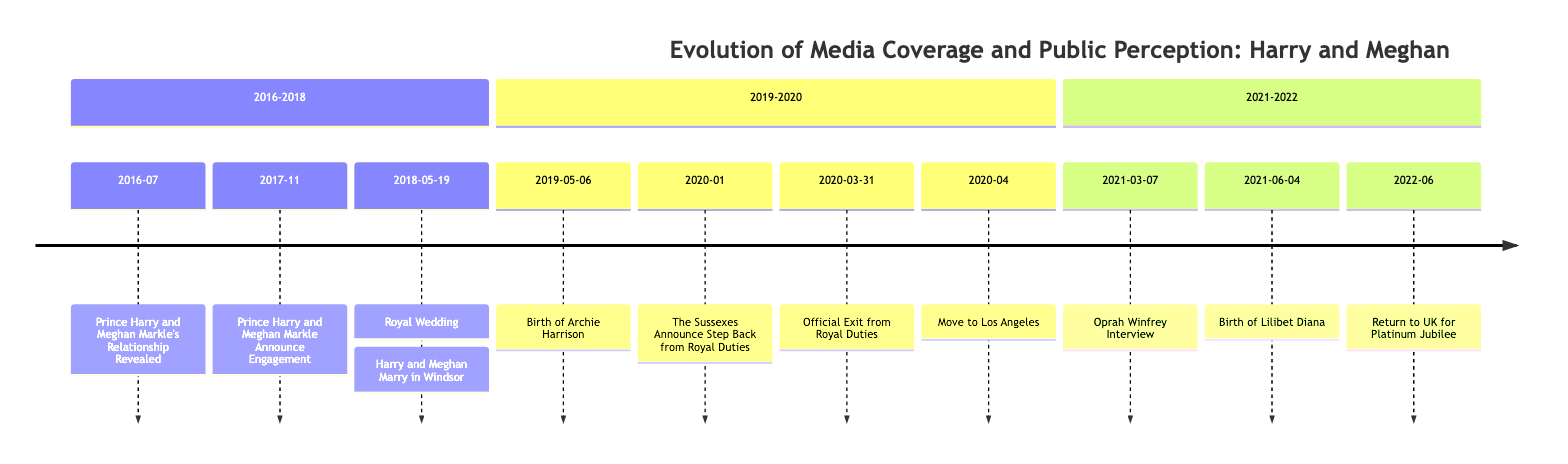What event is marked on 2016-07? The diagram clearly displays that on 2016-07, the event is "Prince Harry and Meghan Markle's Relationship Revealed." This can be seen as a headline under the timeline section.
Answer: Prince Harry and Meghan Markle's Relationship Revealed How many events are listed in the section 2019-2020? In the section titled "2019-2020," there are four events listed: the birth of Archie Harrison, the Sussexes' announcement to step back from royal duties, their official exit from royal duties, and their move to Los Angeles. This can be counted directly from the diagram.
Answer: 4 What major interview was conducted in March 2021? The diagram indicates that the major interview in March 2021 was the "Oprah Winfrey Interview," as it is the headline listed for that date. Therefore, we can directly identify it from the timeline.
Answer: Oprah Winfrey Interview When did the Sussexes officially exit from royal duties? The timeline specifies that the official exit from royal duties took place on 2020-03-31, as this headline is stated right under that date.
Answer: 2020-03-31 Which significant event occurred after the birth of Archie Harrison? From the timeline, it can be noted that after the birth of Archie Harrison on 2019-05-06, the next significant event is the Sussexes' announcement in January 2020 regarding stepping back from royal duties, indicating a major shift in their public perception and role.
Answer: The Sussexes Announce Step Back from Royal Duties How many children do Harry and Meghan have as indicated in the timeline? Reviewing the events, it is clear from the timeline that there are two children mentioned: Archie Harrison, born in May 2019, and Lilibet Diana, born in June 2021. This totals to two children which can be verified from the events listed.
Answer: 2 What is the first major event listed in the diagram? The timeline begins with the event "Prince Harry and Meghan Markle's Relationship Revealed," which is the first event marked on the timeline. This can be identified easily due to its position at the start of the timeline.
Answer: Prince Harry and Meghan Markle's Relationship Revealed What is the significance of June 4, 2021, in the timeline? June 4, 2021, is significant as it marks the "Birth of Lilibet Diana," which is a key milestone in the couple's life and is specifically highlighted as a major event in the timeline, showing its importance in public perception.
Answer: Birth of Lilibet Diana 